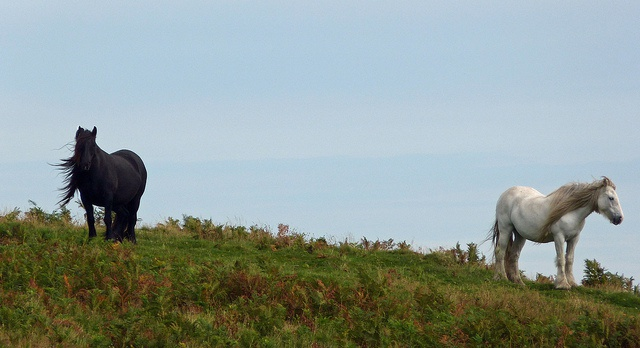Describe the objects in this image and their specific colors. I can see horse in lightblue, gray, darkgray, black, and darkgreen tones and horse in lightblue, black, gray, and darkgray tones in this image. 